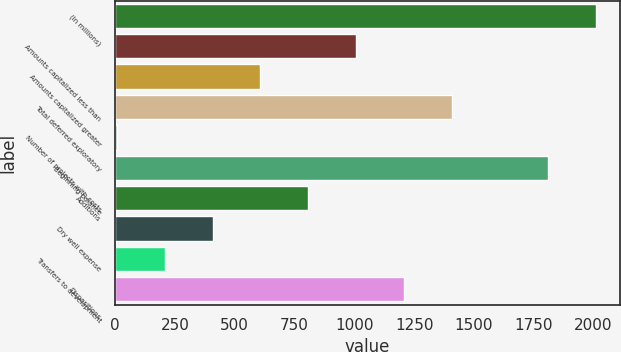Convert chart. <chart><loc_0><loc_0><loc_500><loc_500><bar_chart><fcel>(In millions)<fcel>Amounts capitalized less than<fcel>Amounts capitalized greater<fcel>Total deferred exploratory<fcel>Number of projects with costs<fcel>Beginning balance<fcel>Additions<fcel>Dry well expense<fcel>Transfers to development<fcel>Dispositions<nl><fcel>2010<fcel>1008.5<fcel>607.9<fcel>1409.1<fcel>7<fcel>1809.7<fcel>808.2<fcel>407.6<fcel>207.3<fcel>1208.8<nl></chart> 